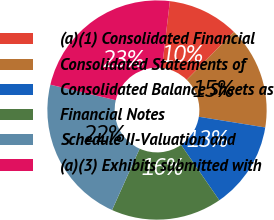Convert chart to OTSL. <chart><loc_0><loc_0><loc_500><loc_500><pie_chart><fcel>(a)(1) Consolidated Financial<fcel>Consolidated Statements of<fcel>Consolidated Balance Sheets as<fcel>Financial Notes<fcel>Schedule II-Valuation and<fcel>(a)(3) Exhibits submitted with<nl><fcel>10.5%<fcel>15.17%<fcel>12.84%<fcel>16.34%<fcel>21.99%<fcel>23.16%<nl></chart> 